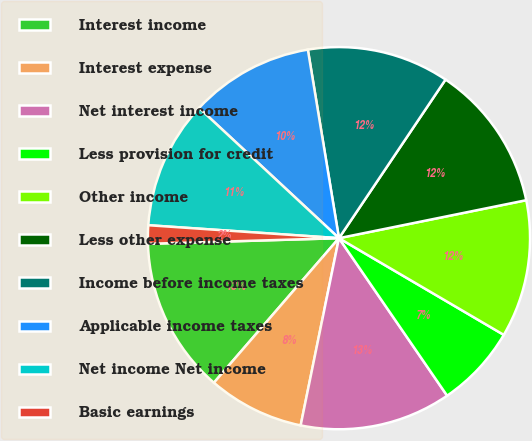<chart> <loc_0><loc_0><loc_500><loc_500><pie_chart><fcel>Interest income<fcel>Interest expense<fcel>Net interest income<fcel>Less provision for credit<fcel>Other income<fcel>Less other expense<fcel>Income before income taxes<fcel>Applicable income taxes<fcel>Net income Net income<fcel>Basic earnings<nl><fcel>13.18%<fcel>8.14%<fcel>12.79%<fcel>6.98%<fcel>11.63%<fcel>12.4%<fcel>12.02%<fcel>10.47%<fcel>10.85%<fcel>1.55%<nl></chart> 